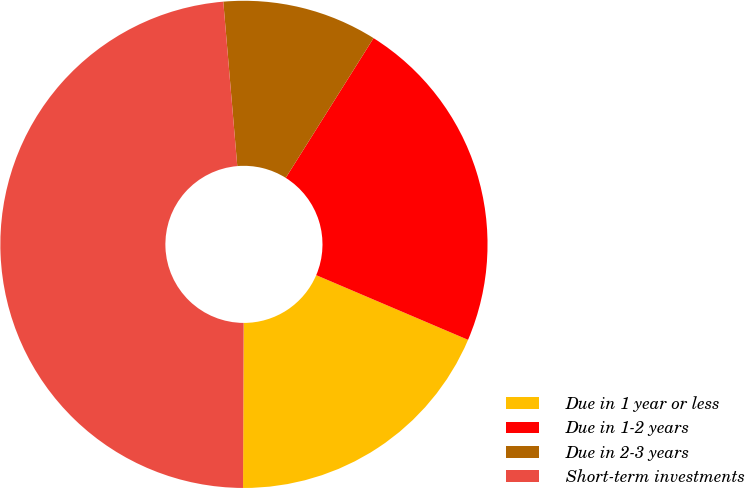Convert chart. <chart><loc_0><loc_0><loc_500><loc_500><pie_chart><fcel>Due in 1 year or less<fcel>Due in 1-2 years<fcel>Due in 2-3 years<fcel>Short-term investments<nl><fcel>18.65%<fcel>22.48%<fcel>10.28%<fcel>48.59%<nl></chart> 